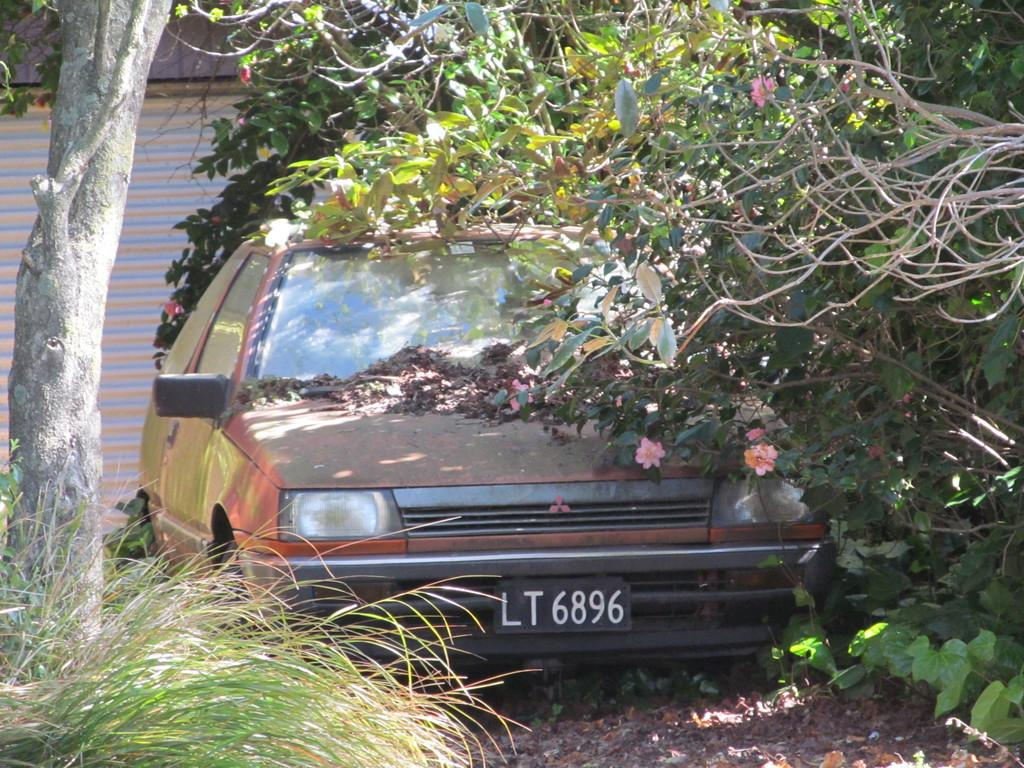What is located on the ground in the image? There is a vehicle on the ground in the image. What can be seen in the background of the image? There are trees, flowers, and a shutter in the background of the image. What type of calculator is visible on the vehicle in the image? There is no calculator present on the vehicle in the image. How many beds can be seen in the image? There are no beds present in the image. 